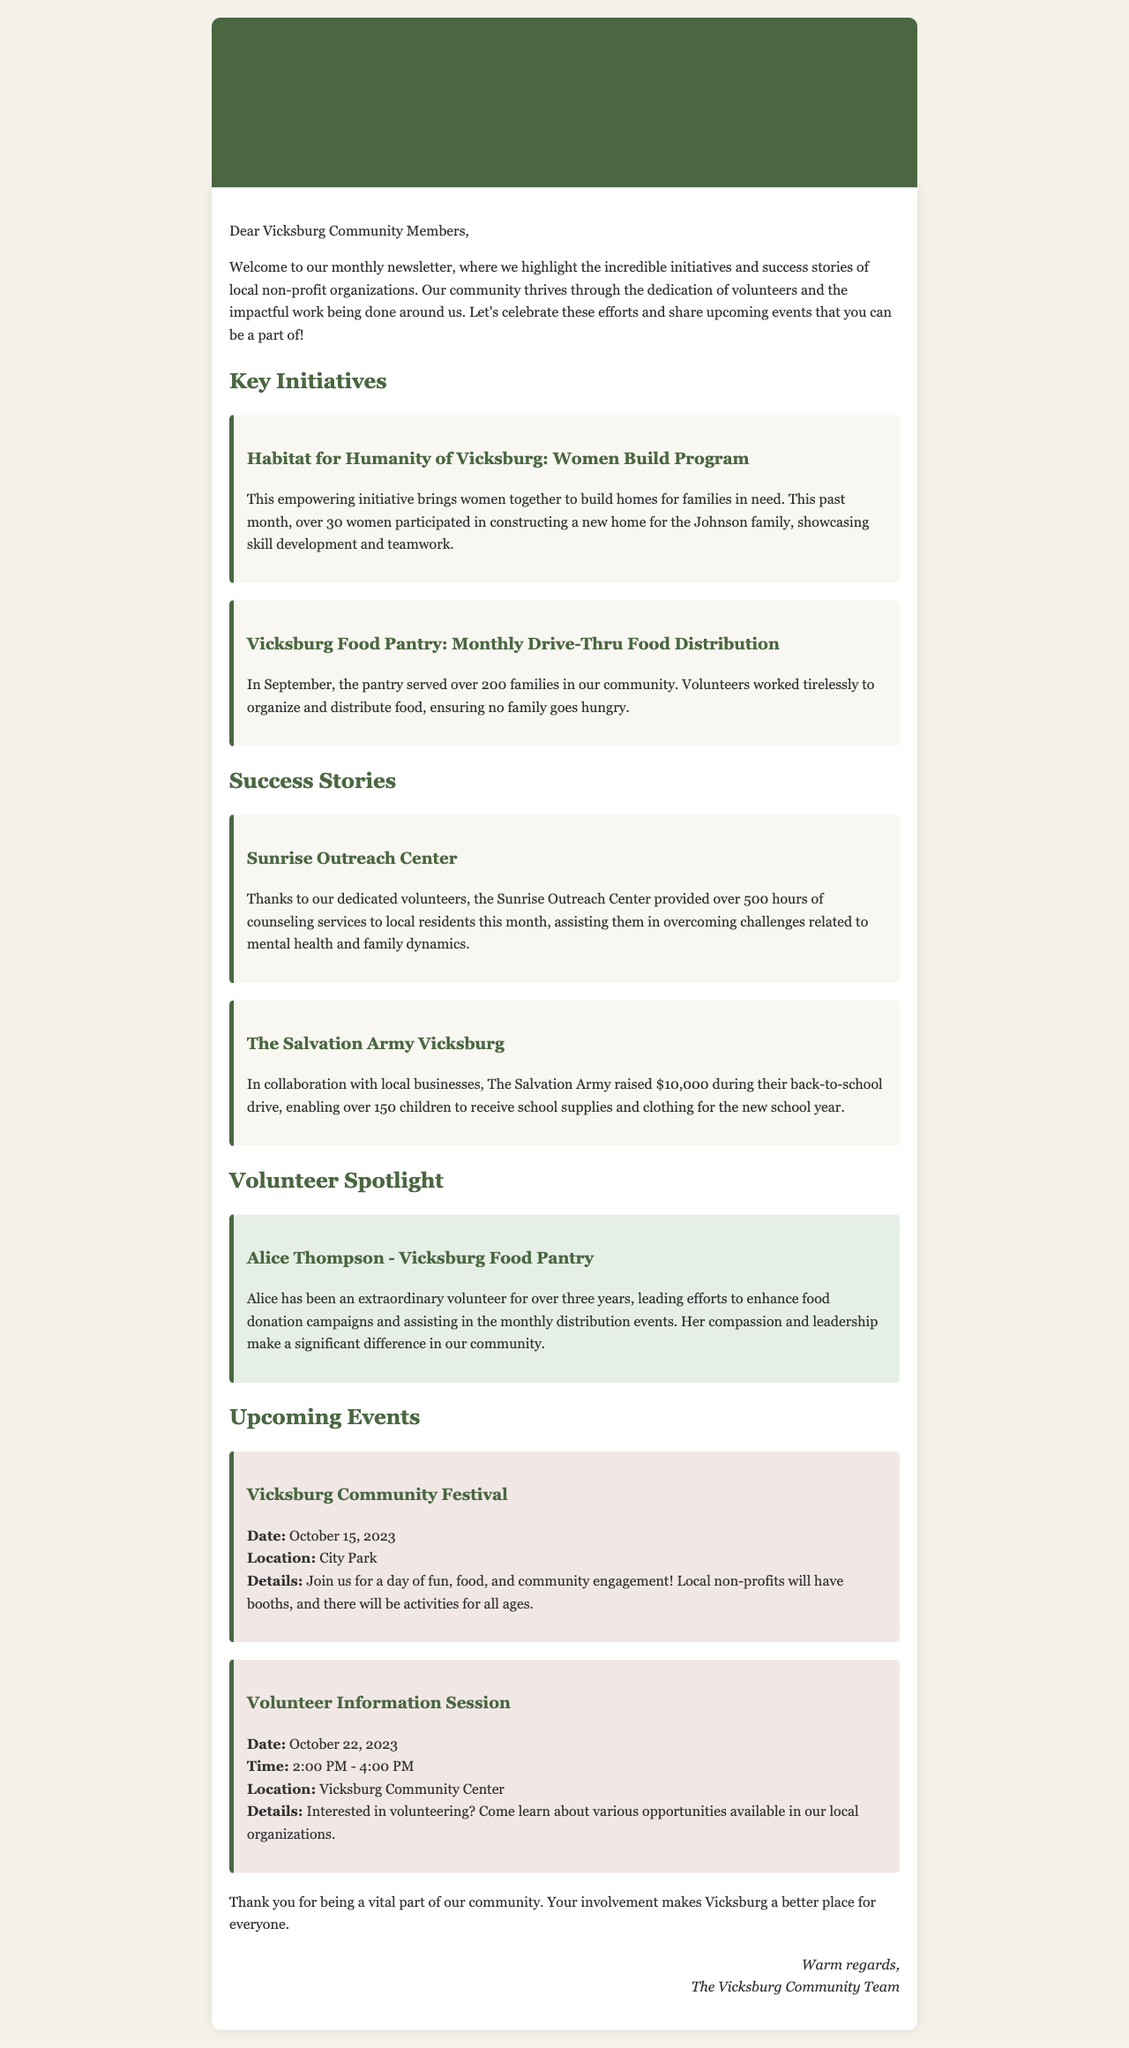What is the name of the program by Habitat for Humanity? The program focuses on empowering women to build homes for families in need, known as the Women Build Program.
Answer: Women Build Program How many families did the Vicksburg Food Pantry serve in September? The document states that over 200 families were served by the pantry in September.
Answer: 200 families Who is the volunteer spotlighted in the newsletter? The spotlight focuses on Alice Thompson for her contributions to the Vicksburg Food Pantry.
Answer: Alice Thompson What amount did The Salvation Army Vicksburg raise during their back-to-school drive? The document specifies that they raised $10,000 during the back-to-school drive.
Answer: $10,000 What is the date of the upcoming Vicksburg Community Festival? The event is scheduled for October 15, 2023, as mentioned in the newsletter.
Answer: October 15, 2023 What type of event is scheduled for October 22, 2023? The event is an information session for potential volunteers.
Answer: Volunteer Information Session How many hours of counseling services did Sunrise Outreach Center provide? The document states that over 500 hours of counseling services were provided to local residents.
Answer: 500 hours What is the primary purpose of the monthly newsletter? The newsletter aims to highlight key initiatives and success stories from local non-profit organizations.
Answer: Highlight initiatives and success stories What is the location of the Volunteer Information Session? The session is set to take place at the Vicksburg Community Center according to the information provided.
Answer: Vicksburg Community Center 